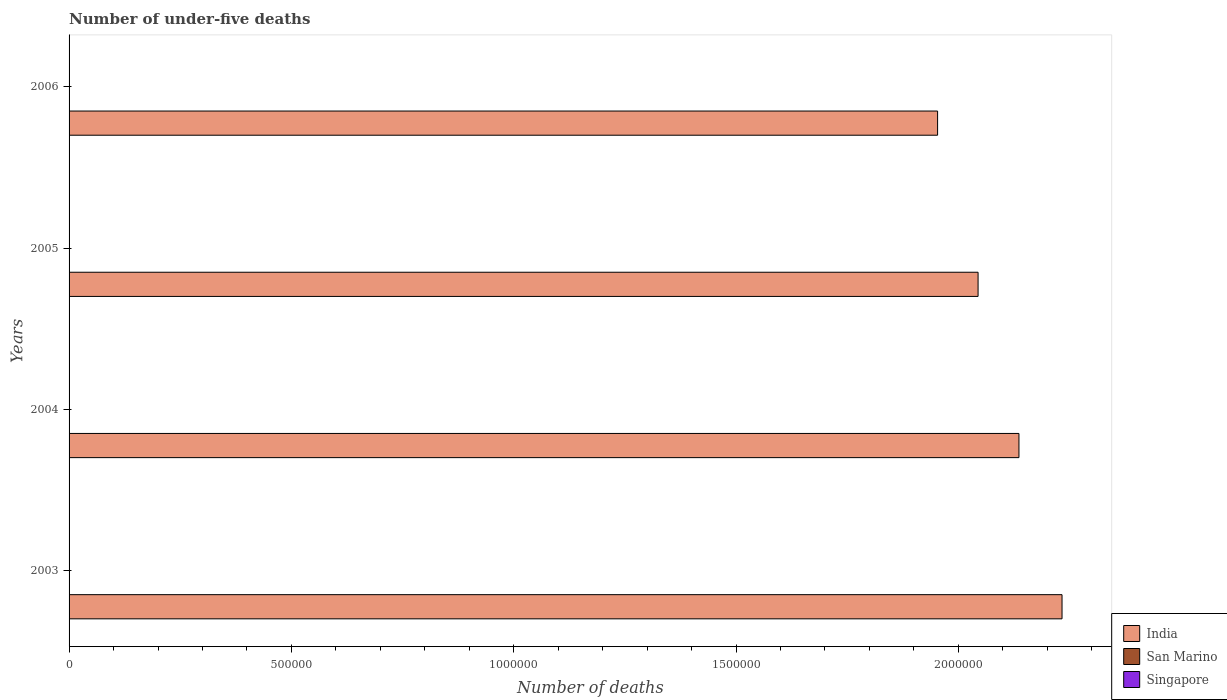How many different coloured bars are there?
Your answer should be very brief. 3. Are the number of bars per tick equal to the number of legend labels?
Provide a succinct answer. Yes. Are the number of bars on each tick of the Y-axis equal?
Offer a terse response. Yes. How many bars are there on the 4th tick from the bottom?
Make the answer very short. 3. What is the label of the 4th group of bars from the top?
Give a very brief answer. 2003. What is the number of under-five deaths in San Marino in 2003?
Keep it short and to the point. 1. Across all years, what is the minimum number of under-five deaths in Singapore?
Provide a short and direct response. 140. In which year was the number of under-five deaths in San Marino maximum?
Ensure brevity in your answer.  2003. In which year was the number of under-five deaths in San Marino minimum?
Keep it short and to the point. 2003. What is the total number of under-five deaths in Singapore in the graph?
Offer a terse response. 567. What is the difference between the number of under-five deaths in Singapore in 2005 and that in 2006?
Give a very brief answer. -2. What is the difference between the number of under-five deaths in Singapore in 2004 and the number of under-five deaths in San Marino in 2005?
Your answer should be compact. 140. What is the average number of under-five deaths in India per year?
Your answer should be compact. 2.09e+06. In the year 2004, what is the difference between the number of under-five deaths in Singapore and number of under-five deaths in India?
Provide a succinct answer. -2.14e+06. In how many years, is the number of under-five deaths in India greater than 600000 ?
Provide a short and direct response. 4. What is the ratio of the number of under-five deaths in San Marino in 2005 to that in 2006?
Your response must be concise. 1. Is the difference between the number of under-five deaths in Singapore in 2003 and 2005 greater than the difference between the number of under-five deaths in India in 2003 and 2005?
Provide a short and direct response. No. What is the difference between the highest and the lowest number of under-five deaths in Singapore?
Keep it short and to the point. 4. In how many years, is the number of under-five deaths in San Marino greater than the average number of under-five deaths in San Marino taken over all years?
Offer a terse response. 0. Is the sum of the number of under-five deaths in India in 2003 and 2006 greater than the maximum number of under-five deaths in Singapore across all years?
Keep it short and to the point. Yes. What does the 1st bar from the top in 2004 represents?
Provide a succinct answer. Singapore. What does the 2nd bar from the bottom in 2003 represents?
Your answer should be compact. San Marino. Is it the case that in every year, the sum of the number of under-five deaths in San Marino and number of under-five deaths in Singapore is greater than the number of under-five deaths in India?
Provide a short and direct response. No. How many bars are there?
Provide a succinct answer. 12. Are all the bars in the graph horizontal?
Your answer should be very brief. Yes. How many years are there in the graph?
Your answer should be very brief. 4. What is the difference between two consecutive major ticks on the X-axis?
Provide a short and direct response. 5.00e+05. Does the graph contain grids?
Offer a very short reply. No. How many legend labels are there?
Provide a short and direct response. 3. How are the legend labels stacked?
Your response must be concise. Vertical. What is the title of the graph?
Your answer should be very brief. Number of under-five deaths. Does "Latin America(all income levels)" appear as one of the legend labels in the graph?
Your answer should be very brief. No. What is the label or title of the X-axis?
Offer a very short reply. Number of deaths. What is the label or title of the Y-axis?
Offer a very short reply. Years. What is the Number of deaths in India in 2003?
Offer a terse response. 2.23e+06. What is the Number of deaths in Singapore in 2003?
Make the answer very short. 144. What is the Number of deaths of India in 2004?
Make the answer very short. 2.14e+06. What is the Number of deaths of San Marino in 2004?
Give a very brief answer. 1. What is the Number of deaths of Singapore in 2004?
Provide a succinct answer. 141. What is the Number of deaths of India in 2005?
Your response must be concise. 2.04e+06. What is the Number of deaths in Singapore in 2005?
Ensure brevity in your answer.  140. What is the Number of deaths in India in 2006?
Give a very brief answer. 1.95e+06. What is the Number of deaths of Singapore in 2006?
Offer a very short reply. 142. Across all years, what is the maximum Number of deaths of India?
Keep it short and to the point. 2.23e+06. Across all years, what is the maximum Number of deaths of Singapore?
Ensure brevity in your answer.  144. Across all years, what is the minimum Number of deaths of India?
Your answer should be very brief. 1.95e+06. Across all years, what is the minimum Number of deaths in Singapore?
Your response must be concise. 140. What is the total Number of deaths of India in the graph?
Provide a succinct answer. 8.37e+06. What is the total Number of deaths of San Marino in the graph?
Your response must be concise. 4. What is the total Number of deaths in Singapore in the graph?
Your answer should be very brief. 567. What is the difference between the Number of deaths in India in 2003 and that in 2004?
Offer a very short reply. 9.69e+04. What is the difference between the Number of deaths of Singapore in 2003 and that in 2004?
Provide a short and direct response. 3. What is the difference between the Number of deaths of India in 2003 and that in 2005?
Provide a succinct answer. 1.89e+05. What is the difference between the Number of deaths in San Marino in 2003 and that in 2005?
Keep it short and to the point. 0. What is the difference between the Number of deaths in India in 2003 and that in 2006?
Make the answer very short. 2.80e+05. What is the difference between the Number of deaths in India in 2004 and that in 2005?
Your answer should be very brief. 9.19e+04. What is the difference between the Number of deaths of Singapore in 2004 and that in 2005?
Your answer should be very brief. 1. What is the difference between the Number of deaths of India in 2004 and that in 2006?
Your answer should be compact. 1.83e+05. What is the difference between the Number of deaths in San Marino in 2004 and that in 2006?
Your answer should be compact. 0. What is the difference between the Number of deaths of India in 2005 and that in 2006?
Provide a short and direct response. 9.11e+04. What is the difference between the Number of deaths of India in 2003 and the Number of deaths of San Marino in 2004?
Your answer should be very brief. 2.23e+06. What is the difference between the Number of deaths of India in 2003 and the Number of deaths of Singapore in 2004?
Your answer should be very brief. 2.23e+06. What is the difference between the Number of deaths in San Marino in 2003 and the Number of deaths in Singapore in 2004?
Make the answer very short. -140. What is the difference between the Number of deaths in India in 2003 and the Number of deaths in San Marino in 2005?
Make the answer very short. 2.23e+06. What is the difference between the Number of deaths of India in 2003 and the Number of deaths of Singapore in 2005?
Provide a short and direct response. 2.23e+06. What is the difference between the Number of deaths in San Marino in 2003 and the Number of deaths in Singapore in 2005?
Your answer should be very brief. -139. What is the difference between the Number of deaths in India in 2003 and the Number of deaths in San Marino in 2006?
Keep it short and to the point. 2.23e+06. What is the difference between the Number of deaths in India in 2003 and the Number of deaths in Singapore in 2006?
Offer a very short reply. 2.23e+06. What is the difference between the Number of deaths of San Marino in 2003 and the Number of deaths of Singapore in 2006?
Offer a terse response. -141. What is the difference between the Number of deaths of India in 2004 and the Number of deaths of San Marino in 2005?
Your answer should be very brief. 2.14e+06. What is the difference between the Number of deaths in India in 2004 and the Number of deaths in Singapore in 2005?
Offer a very short reply. 2.14e+06. What is the difference between the Number of deaths of San Marino in 2004 and the Number of deaths of Singapore in 2005?
Provide a short and direct response. -139. What is the difference between the Number of deaths of India in 2004 and the Number of deaths of San Marino in 2006?
Your answer should be very brief. 2.14e+06. What is the difference between the Number of deaths of India in 2004 and the Number of deaths of Singapore in 2006?
Your answer should be very brief. 2.14e+06. What is the difference between the Number of deaths in San Marino in 2004 and the Number of deaths in Singapore in 2006?
Your answer should be very brief. -141. What is the difference between the Number of deaths in India in 2005 and the Number of deaths in San Marino in 2006?
Offer a terse response. 2.04e+06. What is the difference between the Number of deaths in India in 2005 and the Number of deaths in Singapore in 2006?
Your response must be concise. 2.04e+06. What is the difference between the Number of deaths of San Marino in 2005 and the Number of deaths of Singapore in 2006?
Give a very brief answer. -141. What is the average Number of deaths in India per year?
Ensure brevity in your answer.  2.09e+06. What is the average Number of deaths in Singapore per year?
Provide a succinct answer. 141.75. In the year 2003, what is the difference between the Number of deaths of India and Number of deaths of San Marino?
Provide a succinct answer. 2.23e+06. In the year 2003, what is the difference between the Number of deaths in India and Number of deaths in Singapore?
Give a very brief answer. 2.23e+06. In the year 2003, what is the difference between the Number of deaths in San Marino and Number of deaths in Singapore?
Provide a short and direct response. -143. In the year 2004, what is the difference between the Number of deaths of India and Number of deaths of San Marino?
Offer a terse response. 2.14e+06. In the year 2004, what is the difference between the Number of deaths in India and Number of deaths in Singapore?
Ensure brevity in your answer.  2.14e+06. In the year 2004, what is the difference between the Number of deaths of San Marino and Number of deaths of Singapore?
Your response must be concise. -140. In the year 2005, what is the difference between the Number of deaths of India and Number of deaths of San Marino?
Offer a terse response. 2.04e+06. In the year 2005, what is the difference between the Number of deaths in India and Number of deaths in Singapore?
Offer a terse response. 2.04e+06. In the year 2005, what is the difference between the Number of deaths in San Marino and Number of deaths in Singapore?
Offer a very short reply. -139. In the year 2006, what is the difference between the Number of deaths in India and Number of deaths in San Marino?
Your response must be concise. 1.95e+06. In the year 2006, what is the difference between the Number of deaths in India and Number of deaths in Singapore?
Offer a very short reply. 1.95e+06. In the year 2006, what is the difference between the Number of deaths in San Marino and Number of deaths in Singapore?
Give a very brief answer. -141. What is the ratio of the Number of deaths in India in 2003 to that in 2004?
Your response must be concise. 1.05. What is the ratio of the Number of deaths of San Marino in 2003 to that in 2004?
Offer a very short reply. 1. What is the ratio of the Number of deaths of Singapore in 2003 to that in 2004?
Make the answer very short. 1.02. What is the ratio of the Number of deaths in India in 2003 to that in 2005?
Offer a very short reply. 1.09. What is the ratio of the Number of deaths in San Marino in 2003 to that in 2005?
Your answer should be very brief. 1. What is the ratio of the Number of deaths of Singapore in 2003 to that in 2005?
Keep it short and to the point. 1.03. What is the ratio of the Number of deaths of India in 2003 to that in 2006?
Keep it short and to the point. 1.14. What is the ratio of the Number of deaths in Singapore in 2003 to that in 2006?
Your answer should be compact. 1.01. What is the ratio of the Number of deaths of India in 2004 to that in 2005?
Your response must be concise. 1.04. What is the ratio of the Number of deaths of San Marino in 2004 to that in 2005?
Keep it short and to the point. 1. What is the ratio of the Number of deaths of Singapore in 2004 to that in 2005?
Provide a short and direct response. 1.01. What is the ratio of the Number of deaths in India in 2004 to that in 2006?
Your answer should be very brief. 1.09. What is the ratio of the Number of deaths in San Marino in 2004 to that in 2006?
Your response must be concise. 1. What is the ratio of the Number of deaths in India in 2005 to that in 2006?
Your answer should be compact. 1.05. What is the ratio of the Number of deaths in San Marino in 2005 to that in 2006?
Provide a short and direct response. 1. What is the ratio of the Number of deaths of Singapore in 2005 to that in 2006?
Offer a very short reply. 0.99. What is the difference between the highest and the second highest Number of deaths in India?
Offer a very short reply. 9.69e+04. What is the difference between the highest and the second highest Number of deaths in San Marino?
Provide a short and direct response. 0. What is the difference between the highest and the second highest Number of deaths in Singapore?
Your answer should be compact. 2. What is the difference between the highest and the lowest Number of deaths of India?
Your answer should be very brief. 2.80e+05. What is the difference between the highest and the lowest Number of deaths of San Marino?
Offer a terse response. 0. 